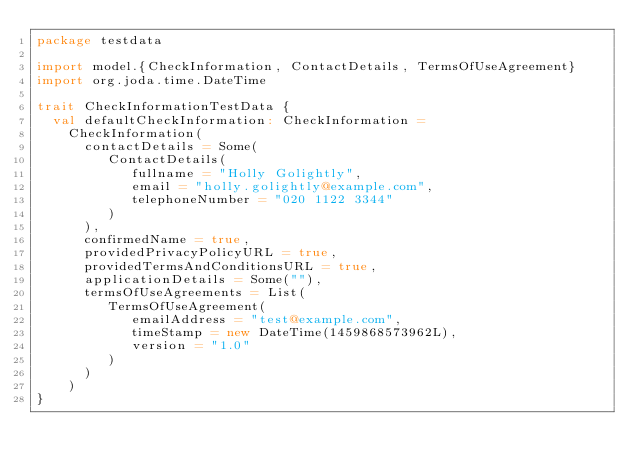<code> <loc_0><loc_0><loc_500><loc_500><_Scala_>package testdata

import model.{CheckInformation, ContactDetails, TermsOfUseAgreement}
import org.joda.time.DateTime

trait CheckInformationTestData {
  val defaultCheckInformation: CheckInformation =
    CheckInformation(
      contactDetails = Some(
         ContactDetails(
            fullname = "Holly Golightly",
            email = "holly.golightly@example.com",
            telephoneNumber = "020 1122 3344"
         )
      ),
      confirmedName = true,
      providedPrivacyPolicyURL = true,
      providedTermsAndConditionsURL = true,
      applicationDetails = Some(""),
      termsOfUseAgreements = List(
         TermsOfUseAgreement(
            emailAddress = "test@example.com",
            timeStamp = new DateTime(1459868573962L),
            version = "1.0"
         )
      )
    )
}
</code> 